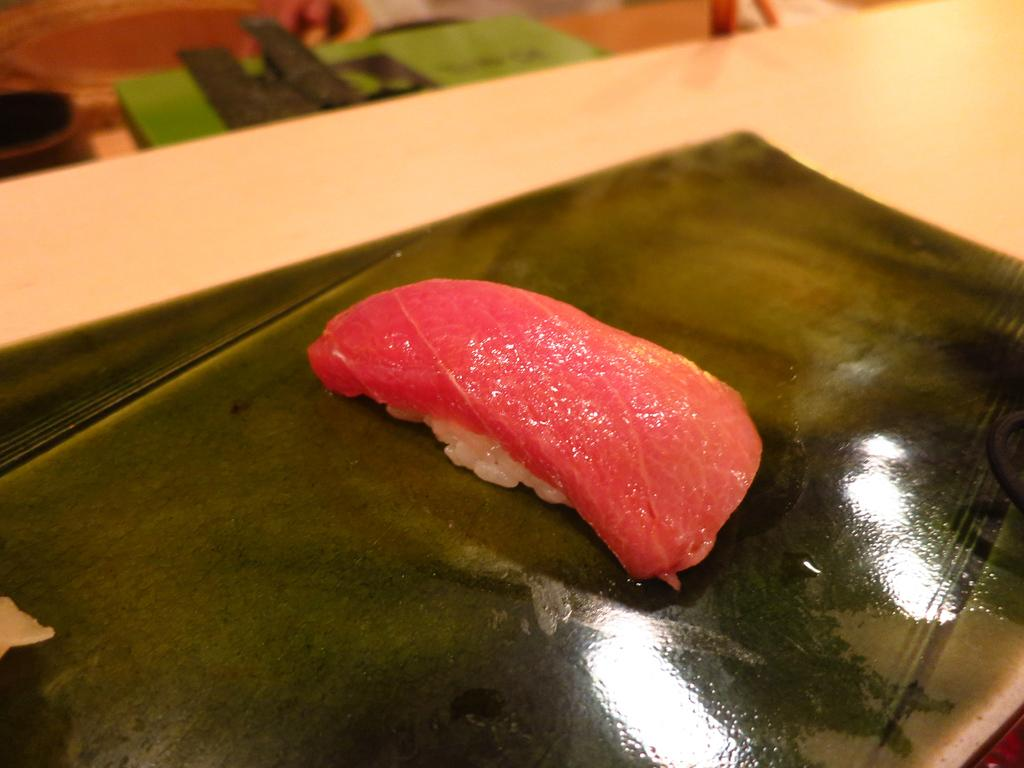What type of food is visible in the image? There is a red meat piece in the image. What color is the plate that the meat piece is on? The plate is black in color. What material is the surface that the plate is placed on? The plate is placed on a wooden table top. How many pieces of furniture can be seen in the image? There is no furniture visible in the image; only a meat piece, a plate, and a table top are present. What type of bit is being used to eat the meat in the image? There is no indication of anyone eating the meat in the image, and therefore no bit can be observed. 